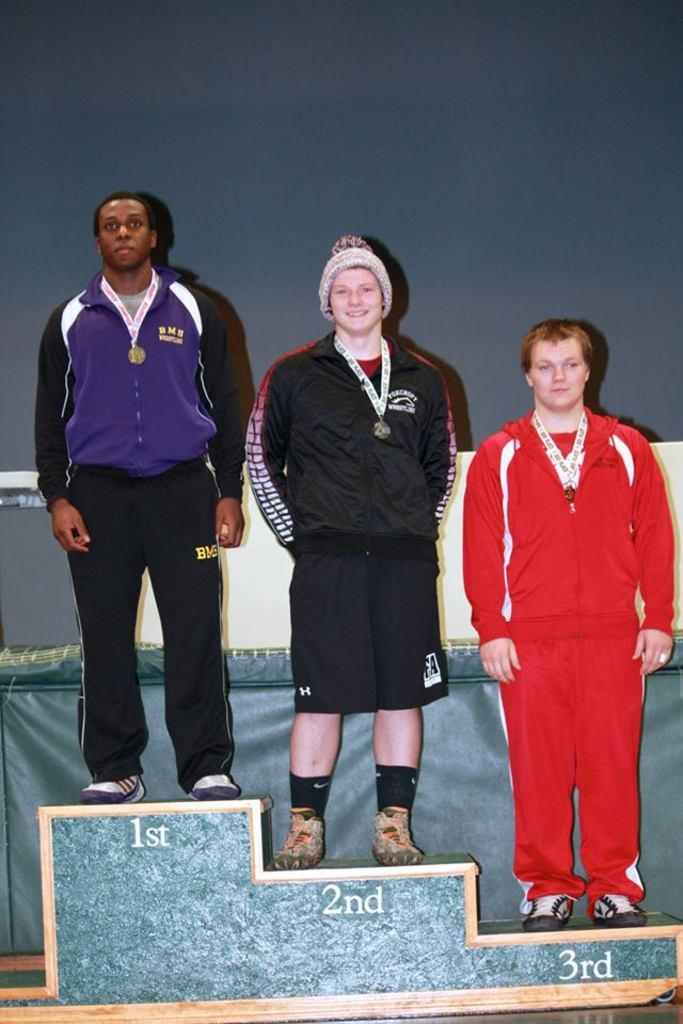Who or what is present in the image? There are people in the image. What are the people wearing? The people are wearing medals. What type of surface are the people standing on? The people are standing on a wooden surface. What time of day is it in the image? The provided facts do not mention the time of day, so we cannot determine if it is the afternoon or any other specific time. 